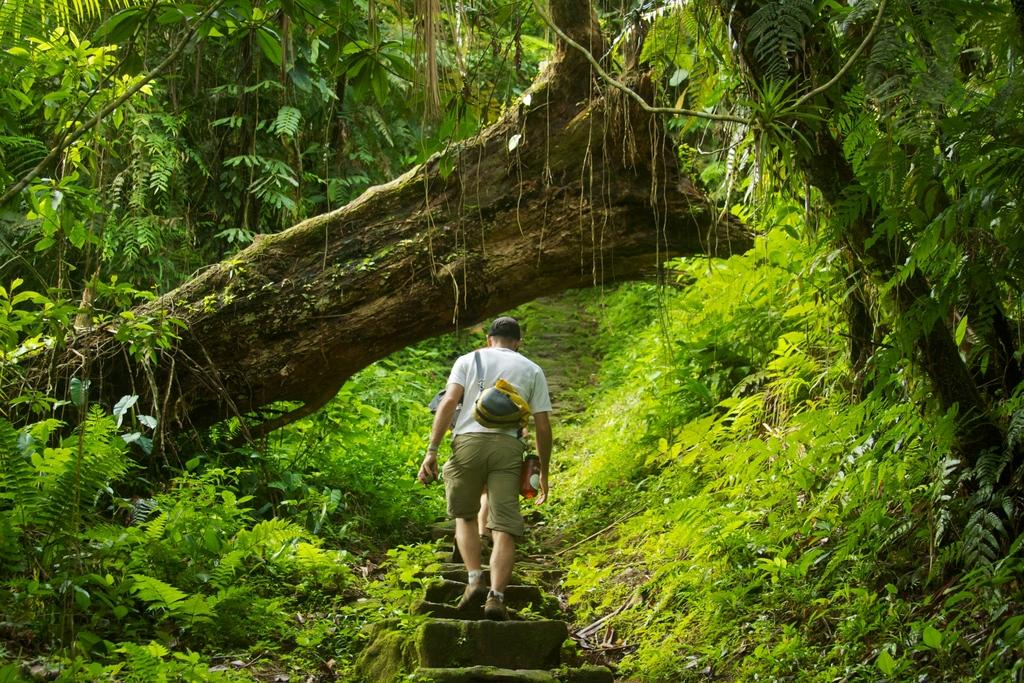What is the person in the image doing? The person in the image is walking upstairs. What can be seen in the background of the image? There is a group of trees in the image. What type of vegetation is around the person in the image? There are plants around the person in the image. What part of a tree is visible in the center of the image? The bark of a tree is visible in the center of the image. What color are the eyes of the person walking upstairs in the image? There is no information about the person's eyes in the image, so we cannot determine their color. 